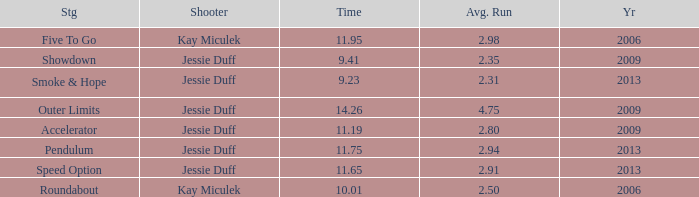What is the total years with average runs less than 4.75 and a time of 14.26? 0.0. 